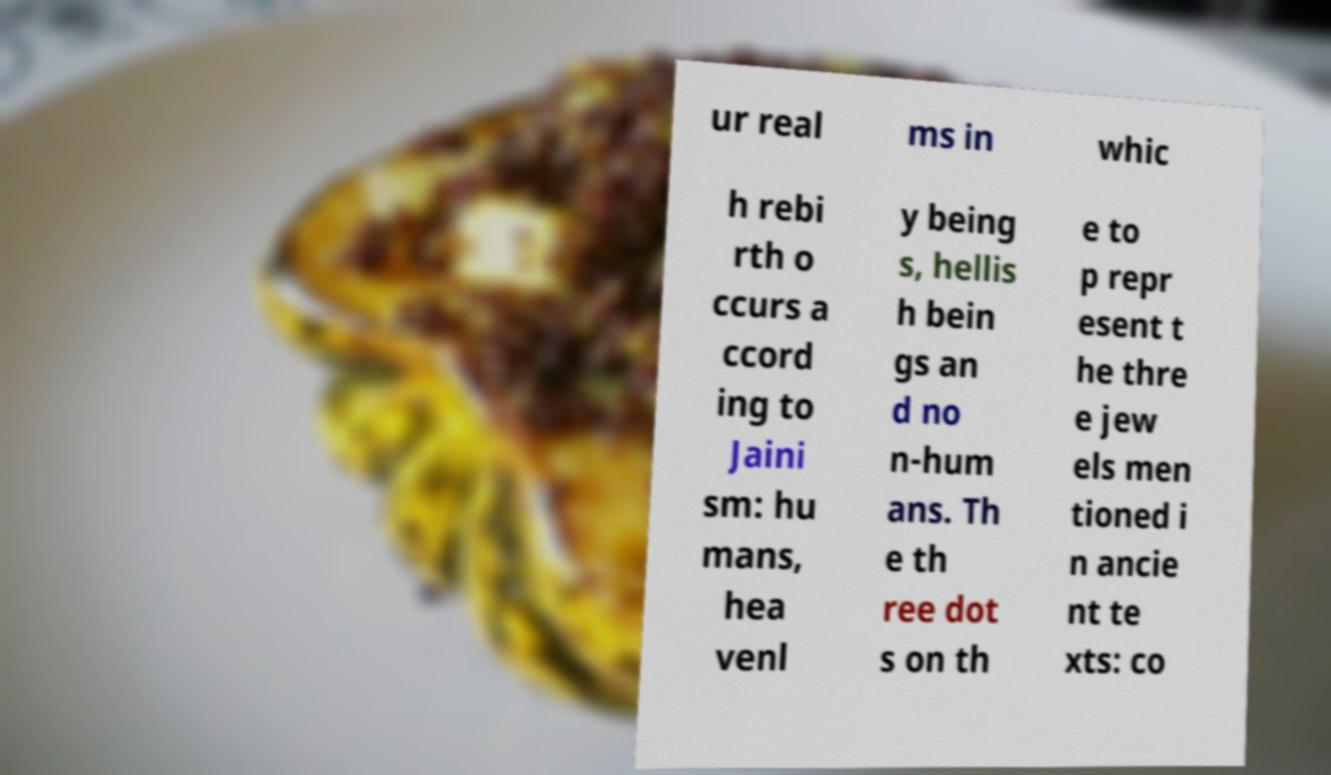For documentation purposes, I need the text within this image transcribed. Could you provide that? ur real ms in whic h rebi rth o ccurs a ccord ing to Jaini sm: hu mans, hea venl y being s, hellis h bein gs an d no n-hum ans. Th e th ree dot s on th e to p repr esent t he thre e jew els men tioned i n ancie nt te xts: co 